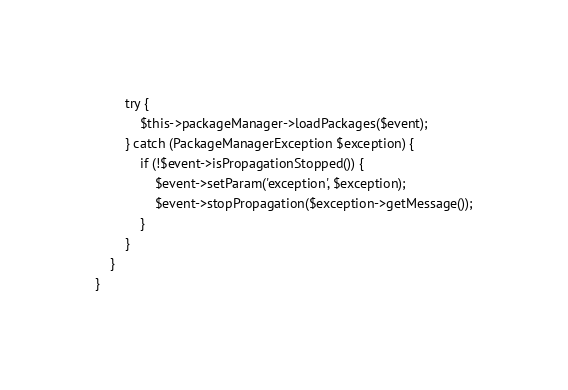<code> <loc_0><loc_0><loc_500><loc_500><_PHP_>        try {
            $this->packageManager->loadPackages($event);
        } catch (PackageManagerException $exception) {
            if (!$event->isPropagationStopped()) {
                $event->setParam('exception', $exception);
                $event->stopPropagation($exception->getMessage());
            }
        }
    }
}
</code> 